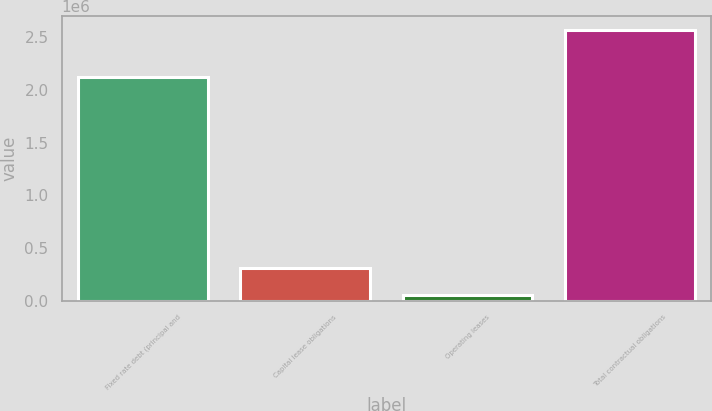<chart> <loc_0><loc_0><loc_500><loc_500><bar_chart><fcel>Fixed rate debt (principal and<fcel>Capital lease obligations<fcel>Operating leases<fcel>Total contractual obligations<nl><fcel>2.1264e+06<fcel>311096<fcel>59924<fcel>2.57164e+06<nl></chart> 